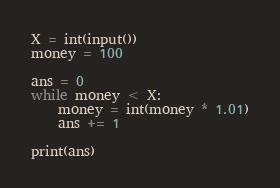<code> <loc_0><loc_0><loc_500><loc_500><_Python_>X = int(input())
money = 100

ans = 0
while money < X:
    money = int(money * 1.01)
    ans += 1

print(ans)
</code> 